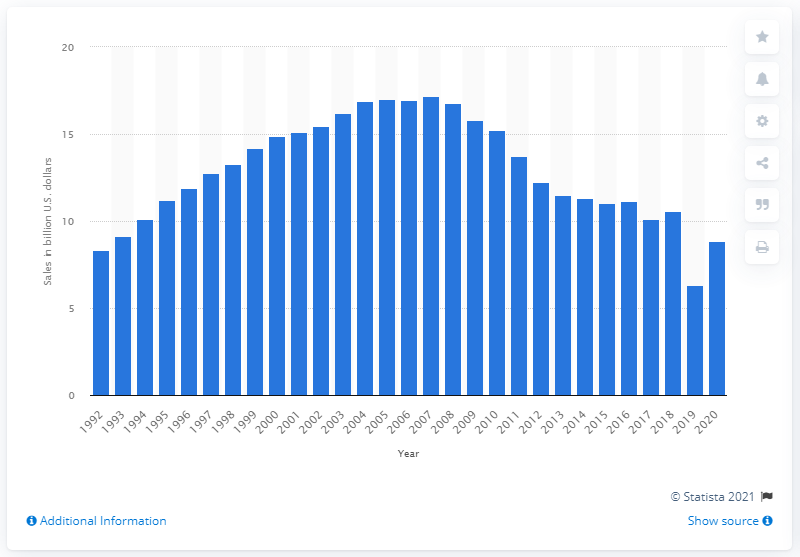Specify some key components in this picture. The previous year's book store sales revenue was 10.6 million dollars. In 2019, U.S. book store sales revenue dropped by 10.6%. 